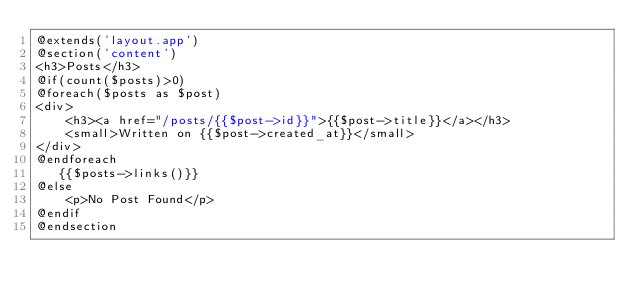<code> <loc_0><loc_0><loc_500><loc_500><_PHP_>@extends('layout.app')
@section('content')
<h3>Posts</h3>
@if(count($posts)>0)
@foreach($posts as $post)
<div> 
    <h3><a href="/posts/{{$post->id}}">{{$post->title}}</a></h3>
    <small>Written on {{$post->created_at}}</small>
</div>
@endforeach
   {{$posts->links()}} 
@else
    <p>No Post Found</p>
@endif
@endsection</code> 